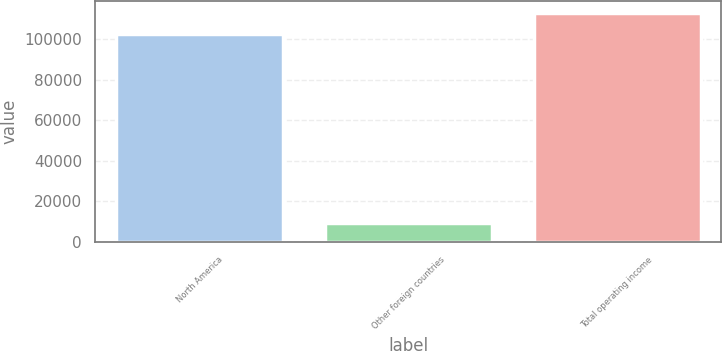<chart> <loc_0><loc_0><loc_500><loc_500><bar_chart><fcel>North America<fcel>Other foreign countries<fcel>Total operating income<nl><fcel>102806<fcel>9549<fcel>113087<nl></chart> 